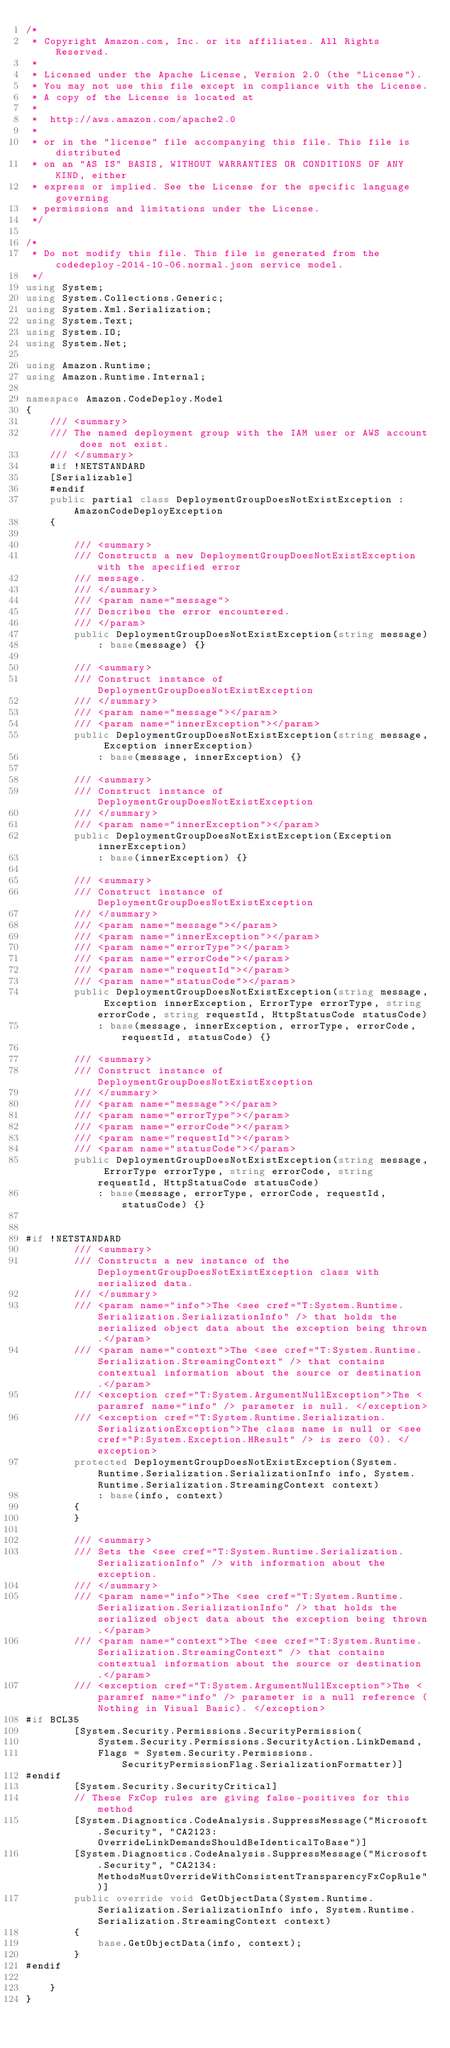<code> <loc_0><loc_0><loc_500><loc_500><_C#_>/*
 * Copyright Amazon.com, Inc. or its affiliates. All Rights Reserved.
 * 
 * Licensed under the Apache License, Version 2.0 (the "License").
 * You may not use this file except in compliance with the License.
 * A copy of the License is located at
 * 
 *  http://aws.amazon.com/apache2.0
 * 
 * or in the "license" file accompanying this file. This file is distributed
 * on an "AS IS" BASIS, WITHOUT WARRANTIES OR CONDITIONS OF ANY KIND, either
 * express or implied. See the License for the specific language governing
 * permissions and limitations under the License.
 */

/*
 * Do not modify this file. This file is generated from the codedeploy-2014-10-06.normal.json service model.
 */
using System;
using System.Collections.Generic;
using System.Xml.Serialization;
using System.Text;
using System.IO;
using System.Net;

using Amazon.Runtime;
using Amazon.Runtime.Internal;

namespace Amazon.CodeDeploy.Model
{
    /// <summary>
    /// The named deployment group with the IAM user or AWS account does not exist.
    /// </summary>
    #if !NETSTANDARD
    [Serializable]
    #endif
    public partial class DeploymentGroupDoesNotExistException : AmazonCodeDeployException
    {

        /// <summary>
        /// Constructs a new DeploymentGroupDoesNotExistException with the specified error
        /// message.
        /// </summary>
        /// <param name="message">
        /// Describes the error encountered.
        /// </param>
        public DeploymentGroupDoesNotExistException(string message) 
            : base(message) {}

        /// <summary>
        /// Construct instance of DeploymentGroupDoesNotExistException
        /// </summary>
        /// <param name="message"></param>
        /// <param name="innerException"></param>
        public DeploymentGroupDoesNotExistException(string message, Exception innerException) 
            : base(message, innerException) {}

        /// <summary>
        /// Construct instance of DeploymentGroupDoesNotExistException
        /// </summary>
        /// <param name="innerException"></param>
        public DeploymentGroupDoesNotExistException(Exception innerException) 
            : base(innerException) {}

        /// <summary>
        /// Construct instance of DeploymentGroupDoesNotExistException
        /// </summary>
        /// <param name="message"></param>
        /// <param name="innerException"></param>
        /// <param name="errorType"></param>
        /// <param name="errorCode"></param>
        /// <param name="requestId"></param>
        /// <param name="statusCode"></param>
        public DeploymentGroupDoesNotExistException(string message, Exception innerException, ErrorType errorType, string errorCode, string requestId, HttpStatusCode statusCode) 
            : base(message, innerException, errorType, errorCode, requestId, statusCode) {}

        /// <summary>
        /// Construct instance of DeploymentGroupDoesNotExistException
        /// </summary>
        /// <param name="message"></param>
        /// <param name="errorType"></param>
        /// <param name="errorCode"></param>
        /// <param name="requestId"></param>
        /// <param name="statusCode"></param>
        public DeploymentGroupDoesNotExistException(string message, ErrorType errorType, string errorCode, string requestId, HttpStatusCode statusCode) 
            : base(message, errorType, errorCode, requestId, statusCode) {}


#if !NETSTANDARD
        /// <summary>
        /// Constructs a new instance of the DeploymentGroupDoesNotExistException class with serialized data.
        /// </summary>
        /// <param name="info">The <see cref="T:System.Runtime.Serialization.SerializationInfo" /> that holds the serialized object data about the exception being thrown.</param>
        /// <param name="context">The <see cref="T:System.Runtime.Serialization.StreamingContext" /> that contains contextual information about the source or destination.</param>
        /// <exception cref="T:System.ArgumentNullException">The <paramref name="info" /> parameter is null. </exception>
        /// <exception cref="T:System.Runtime.Serialization.SerializationException">The class name is null or <see cref="P:System.Exception.HResult" /> is zero (0). </exception>
        protected DeploymentGroupDoesNotExistException(System.Runtime.Serialization.SerializationInfo info, System.Runtime.Serialization.StreamingContext context)
            : base(info, context)
        {
        }

        /// <summary>
        /// Sets the <see cref="T:System.Runtime.Serialization.SerializationInfo" /> with information about the exception.
        /// </summary>
        /// <param name="info">The <see cref="T:System.Runtime.Serialization.SerializationInfo" /> that holds the serialized object data about the exception being thrown.</param>
        /// <param name="context">The <see cref="T:System.Runtime.Serialization.StreamingContext" /> that contains contextual information about the source or destination.</param>
        /// <exception cref="T:System.ArgumentNullException">The <paramref name="info" /> parameter is a null reference (Nothing in Visual Basic). </exception>
#if BCL35
        [System.Security.Permissions.SecurityPermission(
            System.Security.Permissions.SecurityAction.LinkDemand,
            Flags = System.Security.Permissions.SecurityPermissionFlag.SerializationFormatter)]
#endif
        [System.Security.SecurityCritical]
        // These FxCop rules are giving false-positives for this method
        [System.Diagnostics.CodeAnalysis.SuppressMessage("Microsoft.Security", "CA2123:OverrideLinkDemandsShouldBeIdenticalToBase")]
        [System.Diagnostics.CodeAnalysis.SuppressMessage("Microsoft.Security", "CA2134:MethodsMustOverrideWithConsistentTransparencyFxCopRule")]
        public override void GetObjectData(System.Runtime.Serialization.SerializationInfo info, System.Runtime.Serialization.StreamingContext context)
        {
            base.GetObjectData(info, context);
        }
#endif

    }
}</code> 